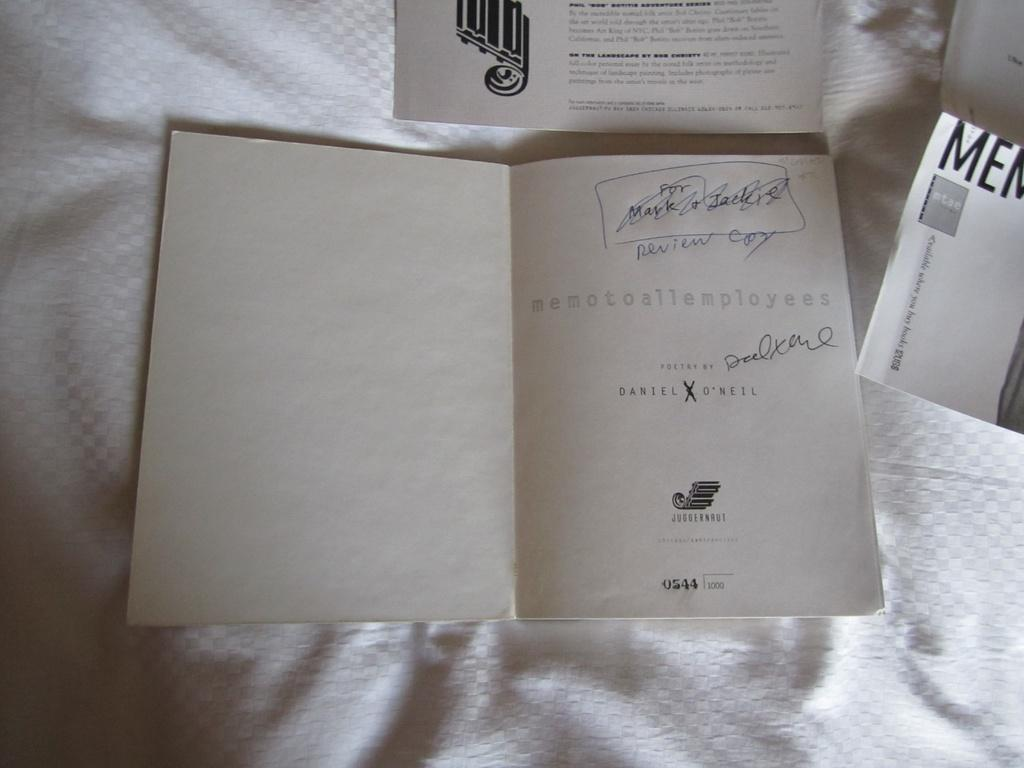<image>
Render a clear and concise summary of the photo. A book of poetry is opened to the first page which reads a memo to to all employees. 